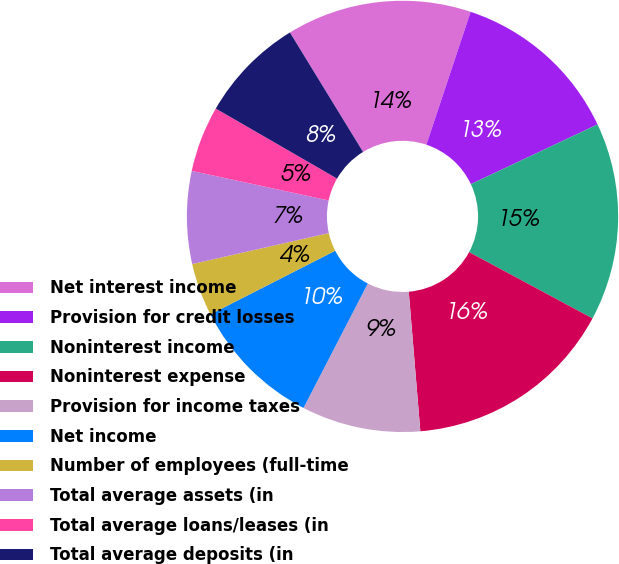Convert chart. <chart><loc_0><loc_0><loc_500><loc_500><pie_chart><fcel>Net interest income<fcel>Provision for credit losses<fcel>Noninterest income<fcel>Noninterest expense<fcel>Provision for income taxes<fcel>Net income<fcel>Number of employees (full-time<fcel>Total average assets (in<fcel>Total average loans/leases (in<fcel>Total average deposits (in<nl><fcel>13.86%<fcel>12.87%<fcel>14.85%<fcel>15.84%<fcel>8.91%<fcel>9.9%<fcel>3.96%<fcel>6.93%<fcel>4.95%<fcel>7.92%<nl></chart> 